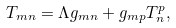Convert formula to latex. <formula><loc_0><loc_0><loc_500><loc_500>T _ { m n } = \Lambda g _ { m n } + g _ { m p } T ^ { p } _ { n } ,</formula> 